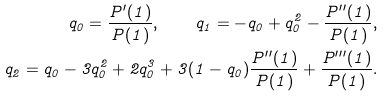Convert formula to latex. <formula><loc_0><loc_0><loc_500><loc_500>q _ { 0 } = \frac { P ^ { \prime } ( 1 ) } { P ( 1 ) } , \quad q _ { 1 } = - q _ { 0 } + q _ { 0 } ^ { 2 } - \frac { P ^ { \prime \prime } ( 1 ) } { P ( 1 ) } , \\ q _ { 2 } = q _ { 0 } - 3 q _ { 0 } ^ { 2 } + 2 q _ { 0 } ^ { 3 } + 3 ( 1 - q _ { 0 } ) \frac { P ^ { \prime \prime } ( 1 ) } { P ( 1 ) } + \frac { P ^ { \prime \prime \prime } ( 1 ) } { P ( 1 ) } .</formula> 